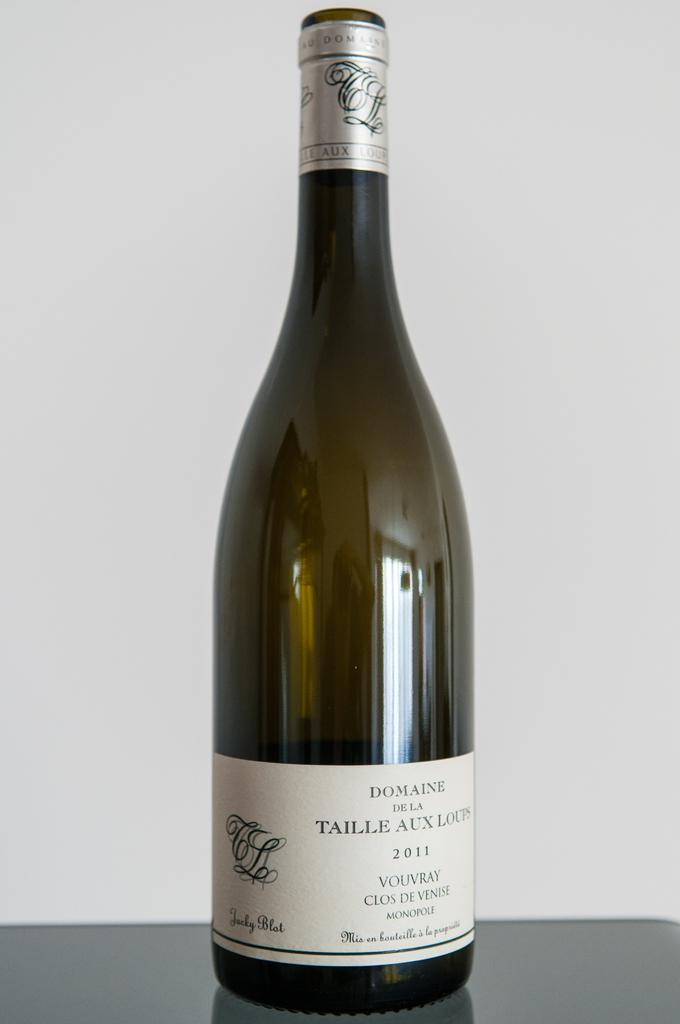<image>
Summarize the visual content of the image. An uncorked bottle of wine form the year 2011 that says "Domaine De la Taille Au Loups" 